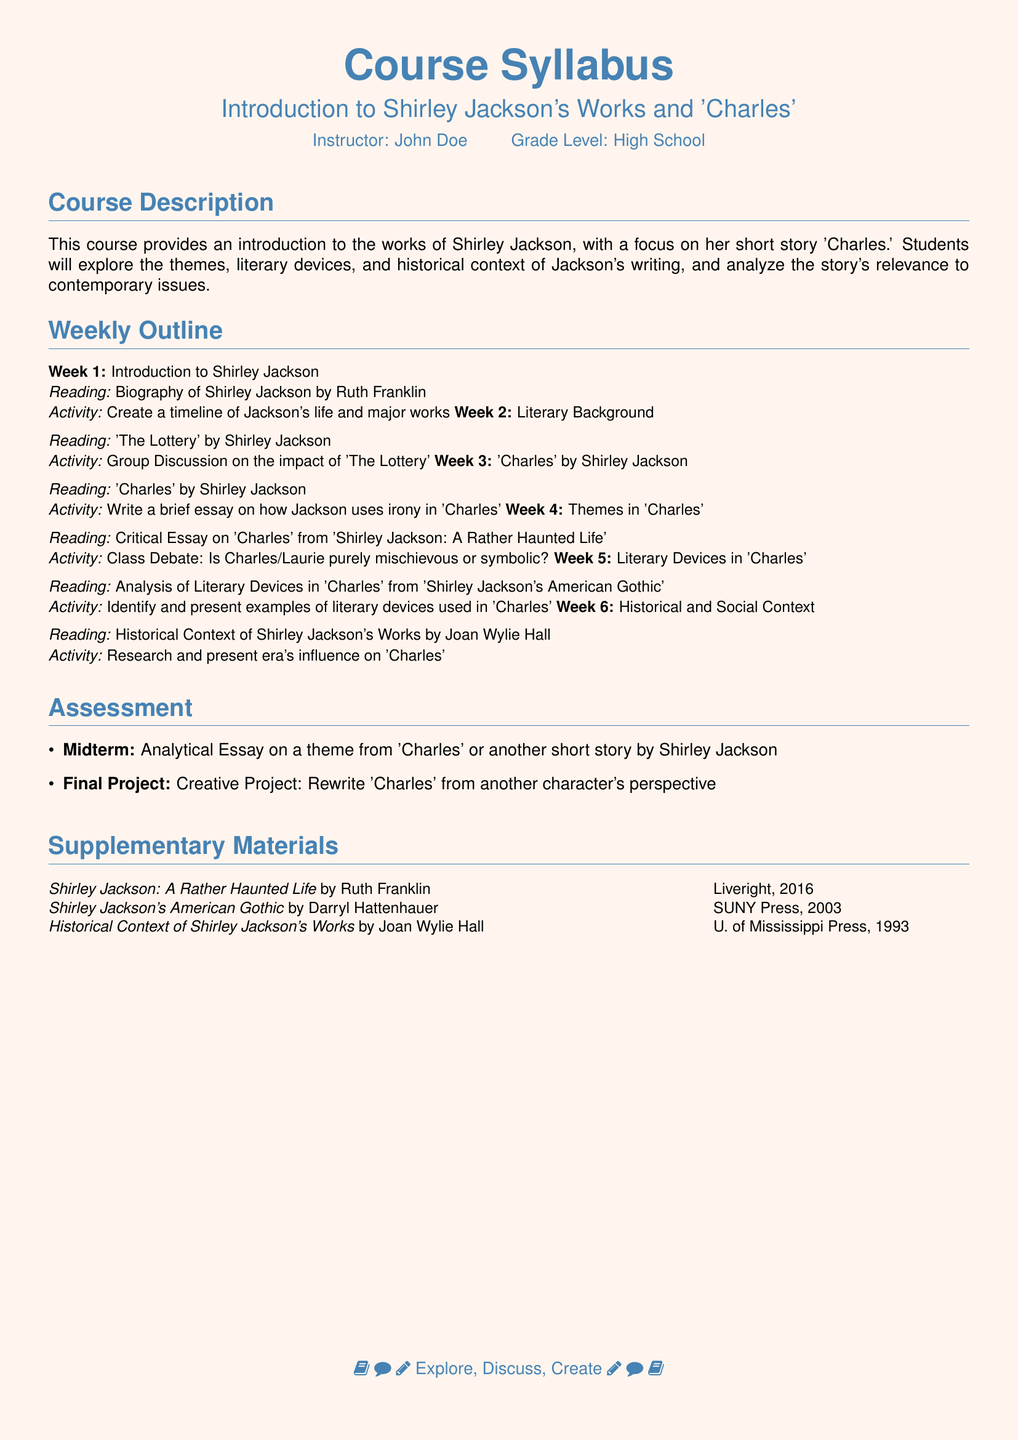What is the course title? The course title is specified at the beginning of the syllabus, which is "Introduction to Shirley Jackson's Works and 'Charles'."
Answer: Introduction to Shirley Jackson's Works and 'Charles' Who is the instructor? The instructor's name appears in the syllabus and is "John Doe."
Answer: John Doe What is the grade level for the course? The grade level is indicated in the syllabus.
Answer: High School How many weeks are planned for the course? The weekly outline section shows the number of weeks planned.
Answer: 6 What is the main focus of Week 3? The main focus of Week 3 is discussing the short story 'Charles' by Shirley Jackson.
Answer: 'Charles' by Shirley Jackson Which literary device is emphasized in Week 5? The outline for Week 5 states that literary devices in 'Charles' will be identified and presented.
Answer: Literary Devices What is the format of the midterm assessment? The midterm assessment is described as an analytical essay.
Answer: Analytical Essay What type of project is assigned as the Final? The Final Project is a creative project that rewrites 'Charles' from another character's perspective.
Answer: Creative Project Which supplementary material was published in 2016? The syllabus lists "Shirley Jackson: A Rather Haunted Life," published in 2016.
Answer: Shirley Jackson: A Rather Haunted Life 